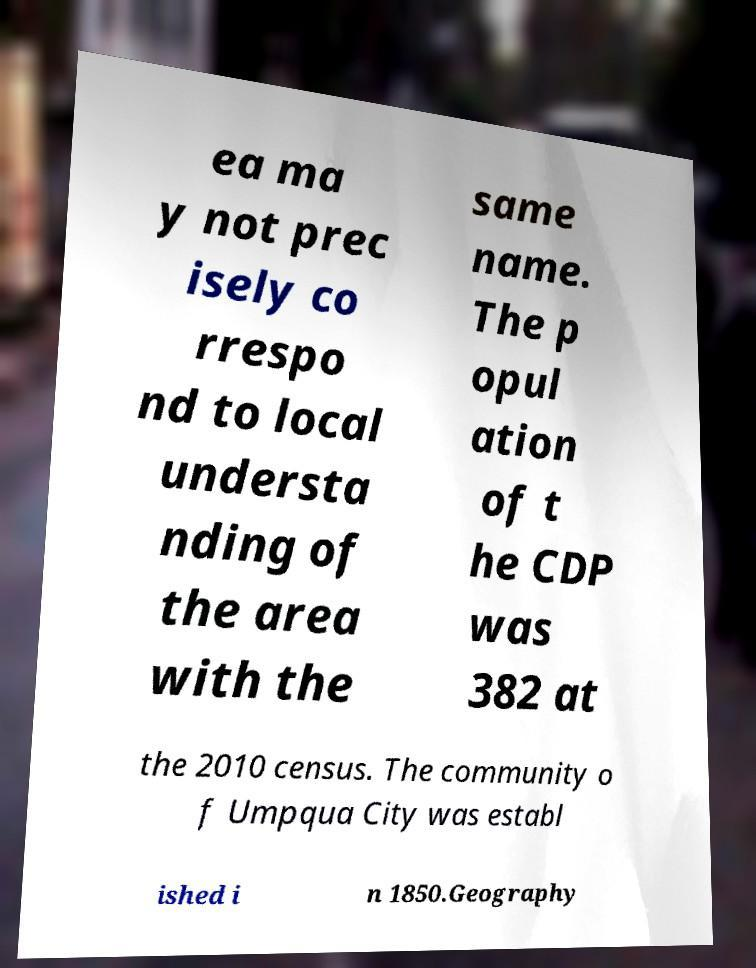I need the written content from this picture converted into text. Can you do that? ea ma y not prec isely co rrespo nd to local understa nding of the area with the same name. The p opul ation of t he CDP was 382 at the 2010 census. The community o f Umpqua City was establ ished i n 1850.Geography 